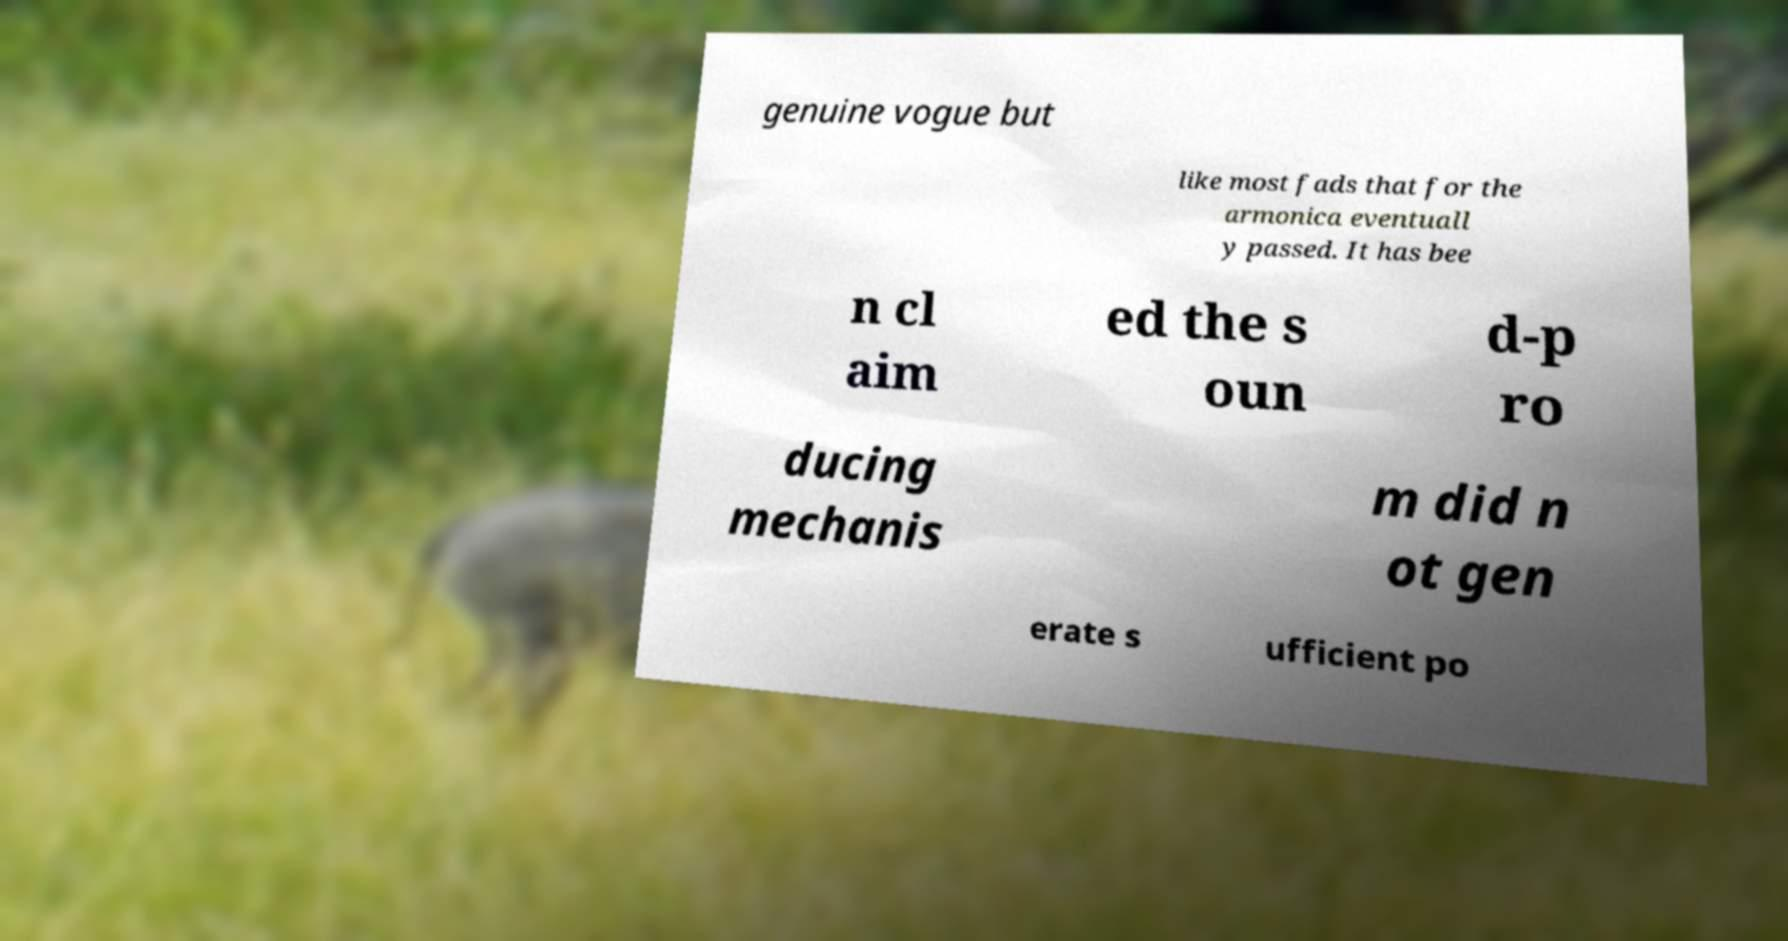Please identify and transcribe the text found in this image. genuine vogue but like most fads that for the armonica eventuall y passed. It has bee n cl aim ed the s oun d-p ro ducing mechanis m did n ot gen erate s ufficient po 